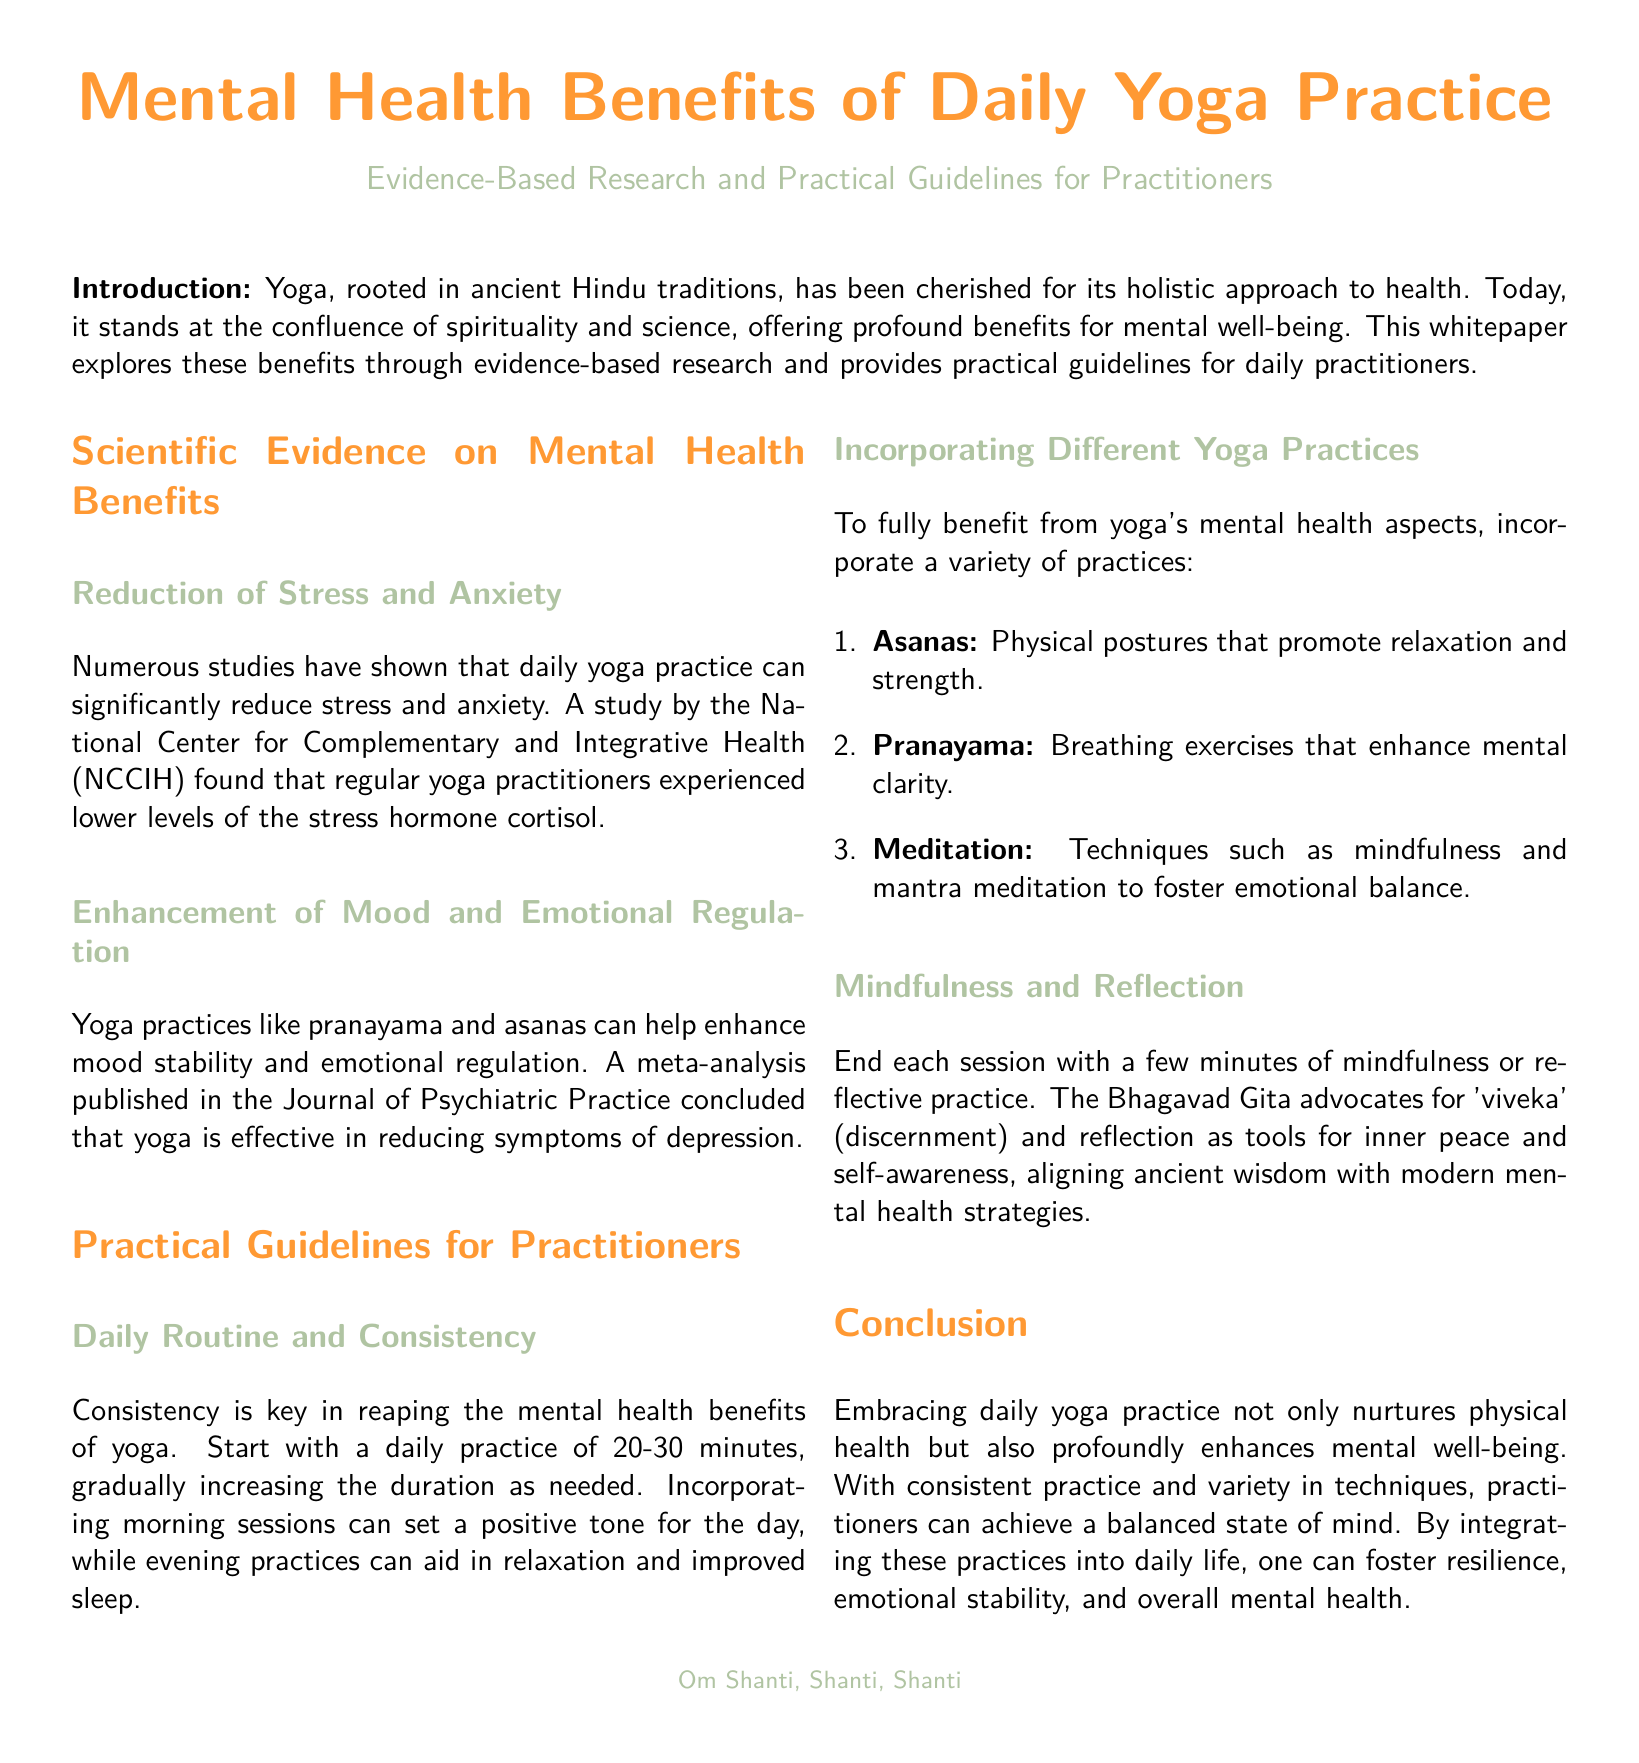What is yoga rooted in? Yoga is rooted in ancient Hindu traditions, which is mentioned in the introduction.
Answer: ancient Hindu traditions What hormone levels are reduced by daily yoga practice? The whitepaper states that regular yoga practitioners experienced lower levels of the stress hormone cortisol.
Answer: cortisol What is recommended for daily practice duration? The document suggests starting with a daily practice of 20-30 minutes, which is mentioned in the practical guidelines section.
Answer: 20-30 minutes Which journal published a meta-analysis on yoga's effectiveness? The Journal of Psychiatric Practice published the meta-analysis discussed in the document.
Answer: Journal of Psychiatric Practice What are the three types of yoga practices recommended? The whitepaper specifically recommends asanas, pranayama, and meditation for mental health benefits.
Answer: asanas, pranayama, meditation What is the term used in the Bhagavad Gita that relates to reflection? The document refers to the term 'viveka' in the context of discernment and reflection.
Answer: viveka How does the introduction characterize yoga? The introduction describes yoga as having a holistic approach to health.
Answer: holistic approach to health What is the concluding message about daily yoga practice? The conclusion emphasizes that embracing daily yoga practice enhances mental well-being.
Answer: enhances mental well-being 